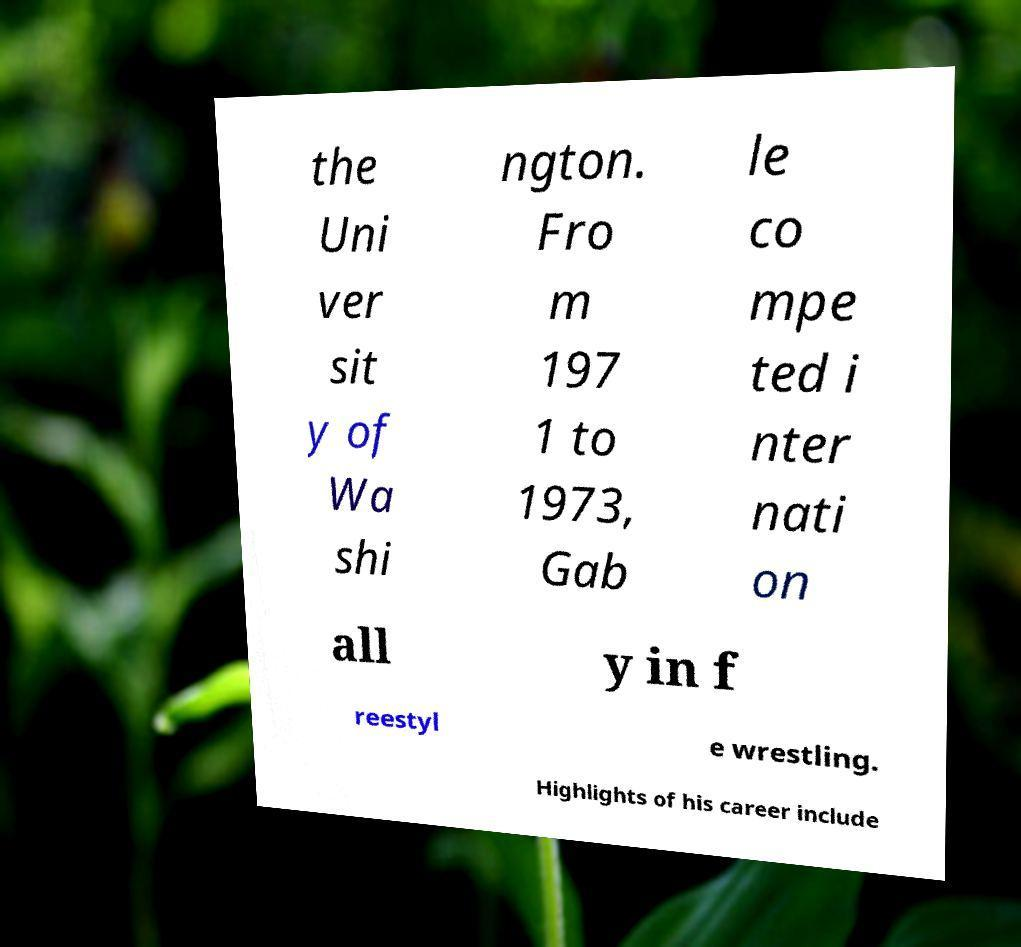Can you read and provide the text displayed in the image?This photo seems to have some interesting text. Can you extract and type it out for me? the Uni ver sit y of Wa shi ngton. Fro m 197 1 to 1973, Gab le co mpe ted i nter nati on all y in f reestyl e wrestling. Highlights of his career include 